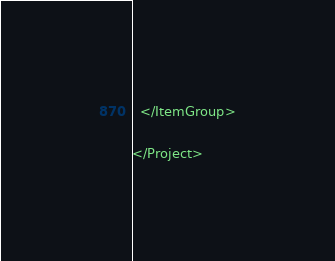Convert code to text. <code><loc_0><loc_0><loc_500><loc_500><_XML_>  </ItemGroup>

</Project>
</code> 